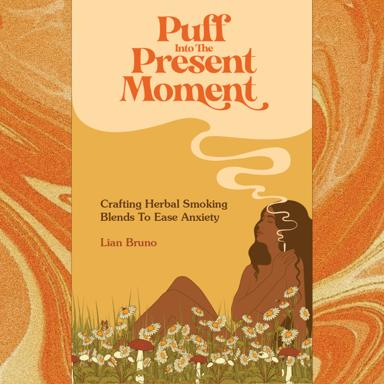Are there any specific plants mentioned in this book that are particularly effective for anxiety relief according to the cover? While the cover does not detail specific plants, it features imagery of a serene natural setting with various herbs and flowers. This suggests a focus on botanicals commonly associated with calm and relaxation, which might include lavender, chamomile, or mint, known for their soothing properties. 